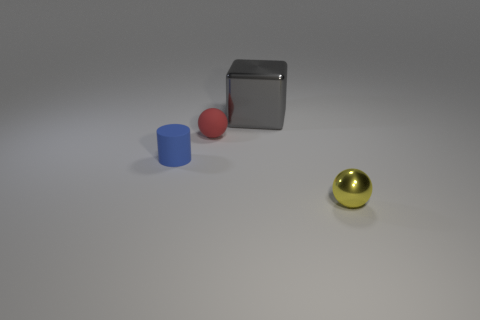Add 2 blue rubber cylinders. How many objects exist? 6 Subtract all red spheres. How many spheres are left? 1 Subtract all green shiny cylinders. Subtract all cubes. How many objects are left? 3 Add 3 yellow shiny things. How many yellow shiny things are left? 4 Add 3 gray blocks. How many gray blocks exist? 4 Subtract 1 yellow spheres. How many objects are left? 3 Subtract 1 blocks. How many blocks are left? 0 Subtract all yellow balls. Subtract all gray cylinders. How many balls are left? 1 Subtract all gray balls. How many yellow cubes are left? 0 